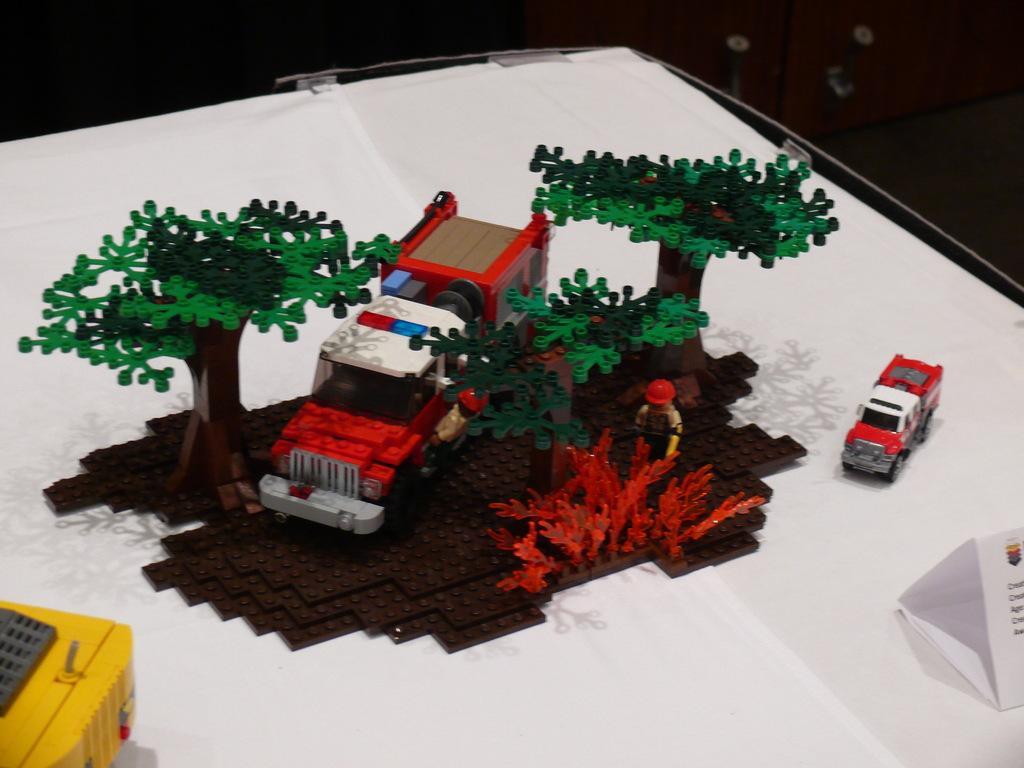Describe this image in one or two sentences. In this image there are few toys on the table having a name board on it. A vehicle toy is in between the tree toys. A person toy is behind a plant. Left bottom there is a toy. Right side there is a vehicle toy on the table. 